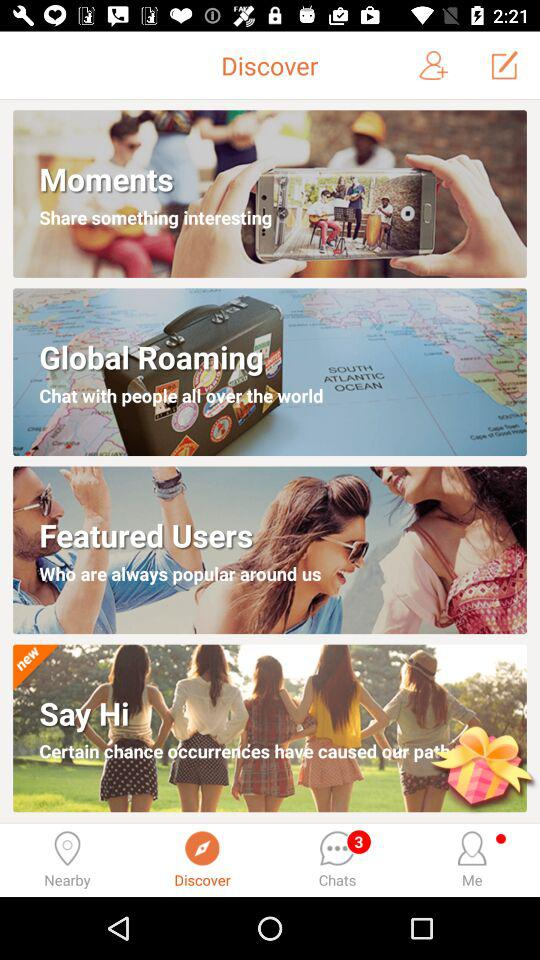Are there any unread chats? There are 3 unread chats. 